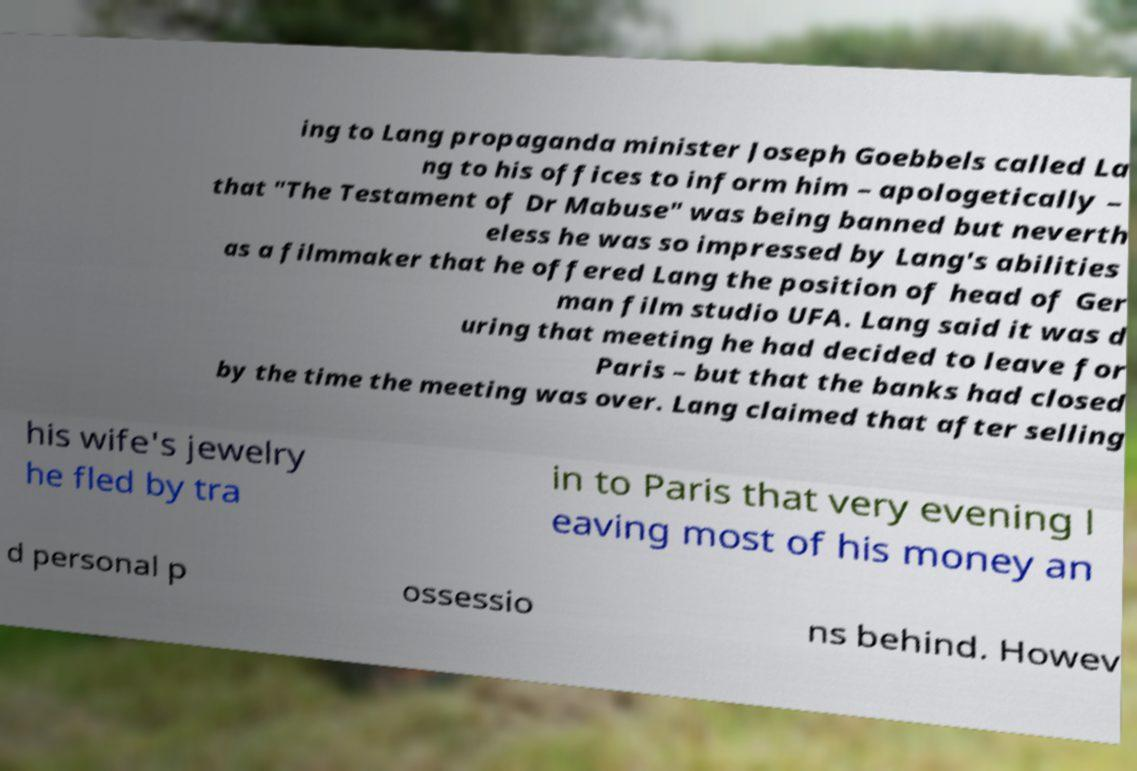Please identify and transcribe the text found in this image. ing to Lang propaganda minister Joseph Goebbels called La ng to his offices to inform him – apologetically – that "The Testament of Dr Mabuse" was being banned but neverth eless he was so impressed by Lang's abilities as a filmmaker that he offered Lang the position of head of Ger man film studio UFA. Lang said it was d uring that meeting he had decided to leave for Paris – but that the banks had closed by the time the meeting was over. Lang claimed that after selling his wife's jewelry he fled by tra in to Paris that very evening l eaving most of his money an d personal p ossessio ns behind. Howev 